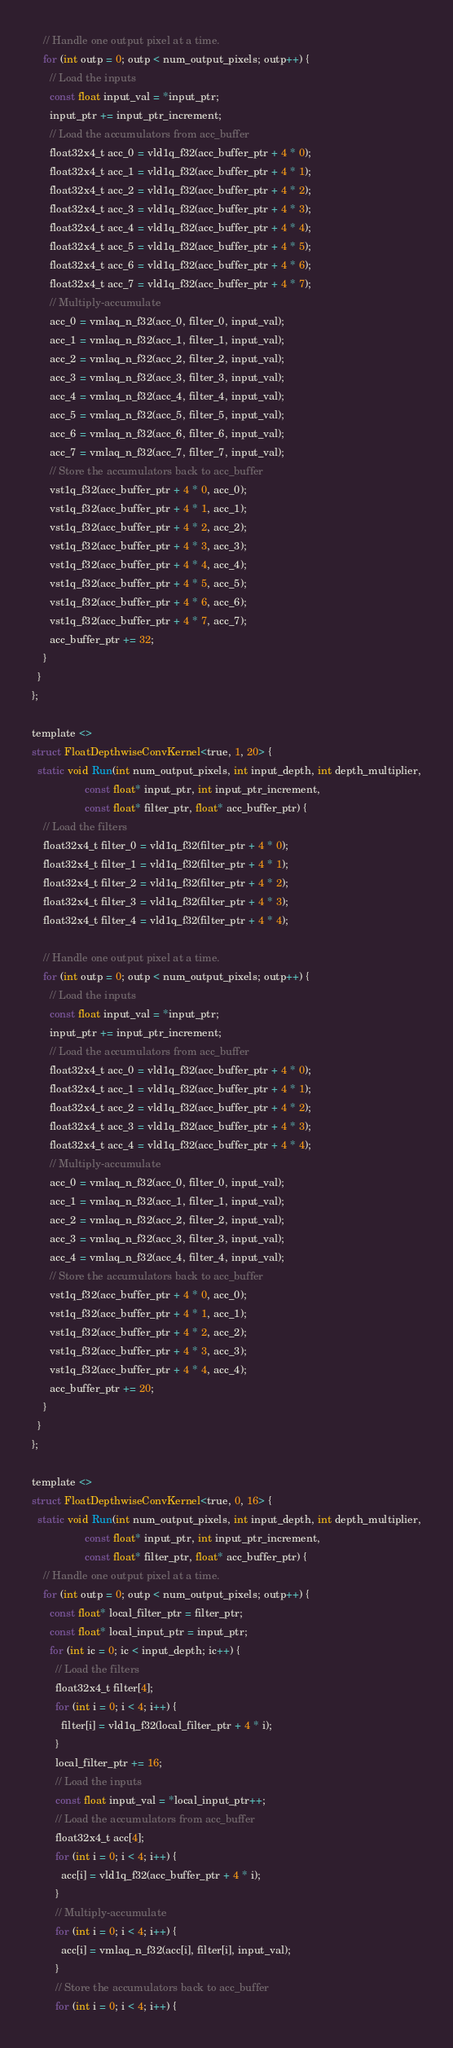Convert code to text. <code><loc_0><loc_0><loc_500><loc_500><_C_>    // Handle one output pixel at a time.
    for (int outp = 0; outp < num_output_pixels; outp++) {
      // Load the inputs
      const float input_val = *input_ptr;
      input_ptr += input_ptr_increment;
      // Load the accumulators from acc_buffer
      float32x4_t acc_0 = vld1q_f32(acc_buffer_ptr + 4 * 0);
      float32x4_t acc_1 = vld1q_f32(acc_buffer_ptr + 4 * 1);
      float32x4_t acc_2 = vld1q_f32(acc_buffer_ptr + 4 * 2);
      float32x4_t acc_3 = vld1q_f32(acc_buffer_ptr + 4 * 3);
      float32x4_t acc_4 = vld1q_f32(acc_buffer_ptr + 4 * 4);
      float32x4_t acc_5 = vld1q_f32(acc_buffer_ptr + 4 * 5);
      float32x4_t acc_6 = vld1q_f32(acc_buffer_ptr + 4 * 6);
      float32x4_t acc_7 = vld1q_f32(acc_buffer_ptr + 4 * 7);
      // Multiply-accumulate
      acc_0 = vmlaq_n_f32(acc_0, filter_0, input_val);
      acc_1 = vmlaq_n_f32(acc_1, filter_1, input_val);
      acc_2 = vmlaq_n_f32(acc_2, filter_2, input_val);
      acc_3 = vmlaq_n_f32(acc_3, filter_3, input_val);
      acc_4 = vmlaq_n_f32(acc_4, filter_4, input_val);
      acc_5 = vmlaq_n_f32(acc_5, filter_5, input_val);
      acc_6 = vmlaq_n_f32(acc_6, filter_6, input_val);
      acc_7 = vmlaq_n_f32(acc_7, filter_7, input_val);
      // Store the accumulators back to acc_buffer
      vst1q_f32(acc_buffer_ptr + 4 * 0, acc_0);
      vst1q_f32(acc_buffer_ptr + 4 * 1, acc_1);
      vst1q_f32(acc_buffer_ptr + 4 * 2, acc_2);
      vst1q_f32(acc_buffer_ptr + 4 * 3, acc_3);
      vst1q_f32(acc_buffer_ptr + 4 * 4, acc_4);
      vst1q_f32(acc_buffer_ptr + 4 * 5, acc_5);
      vst1q_f32(acc_buffer_ptr + 4 * 6, acc_6);
      vst1q_f32(acc_buffer_ptr + 4 * 7, acc_7);
      acc_buffer_ptr += 32;
    }
  }
};

template <>
struct FloatDepthwiseConvKernel<true, 1, 20> {
  static void Run(int num_output_pixels, int input_depth, int depth_multiplier,
                  const float* input_ptr, int input_ptr_increment,
                  const float* filter_ptr, float* acc_buffer_ptr) {
    // Load the filters
    float32x4_t filter_0 = vld1q_f32(filter_ptr + 4 * 0);
    float32x4_t filter_1 = vld1q_f32(filter_ptr + 4 * 1);
    float32x4_t filter_2 = vld1q_f32(filter_ptr + 4 * 2);
    float32x4_t filter_3 = vld1q_f32(filter_ptr + 4 * 3);
    float32x4_t filter_4 = vld1q_f32(filter_ptr + 4 * 4);

    // Handle one output pixel at a time.
    for (int outp = 0; outp < num_output_pixels; outp++) {
      // Load the inputs
      const float input_val = *input_ptr;
      input_ptr += input_ptr_increment;
      // Load the accumulators from acc_buffer
      float32x4_t acc_0 = vld1q_f32(acc_buffer_ptr + 4 * 0);
      float32x4_t acc_1 = vld1q_f32(acc_buffer_ptr + 4 * 1);
      float32x4_t acc_2 = vld1q_f32(acc_buffer_ptr + 4 * 2);
      float32x4_t acc_3 = vld1q_f32(acc_buffer_ptr + 4 * 3);
      float32x4_t acc_4 = vld1q_f32(acc_buffer_ptr + 4 * 4);
      // Multiply-accumulate
      acc_0 = vmlaq_n_f32(acc_0, filter_0, input_val);
      acc_1 = vmlaq_n_f32(acc_1, filter_1, input_val);
      acc_2 = vmlaq_n_f32(acc_2, filter_2, input_val);
      acc_3 = vmlaq_n_f32(acc_3, filter_3, input_val);
      acc_4 = vmlaq_n_f32(acc_4, filter_4, input_val);
      // Store the accumulators back to acc_buffer
      vst1q_f32(acc_buffer_ptr + 4 * 0, acc_0);
      vst1q_f32(acc_buffer_ptr + 4 * 1, acc_1);
      vst1q_f32(acc_buffer_ptr + 4 * 2, acc_2);
      vst1q_f32(acc_buffer_ptr + 4 * 3, acc_3);
      vst1q_f32(acc_buffer_ptr + 4 * 4, acc_4);
      acc_buffer_ptr += 20;
    }
  }
};

template <>
struct FloatDepthwiseConvKernel<true, 0, 16> {
  static void Run(int num_output_pixels, int input_depth, int depth_multiplier,
                  const float* input_ptr, int input_ptr_increment,
                  const float* filter_ptr, float* acc_buffer_ptr) {
    // Handle one output pixel at a time.
    for (int outp = 0; outp < num_output_pixels; outp++) {
      const float* local_filter_ptr = filter_ptr;
      const float* local_input_ptr = input_ptr;
      for (int ic = 0; ic < input_depth; ic++) {
        // Load the filters
        float32x4_t filter[4];
        for (int i = 0; i < 4; i++) {
          filter[i] = vld1q_f32(local_filter_ptr + 4 * i);
        }
        local_filter_ptr += 16;
        // Load the inputs
        const float input_val = *local_input_ptr++;
        // Load the accumulators from acc_buffer
        float32x4_t acc[4];
        for (int i = 0; i < 4; i++) {
          acc[i] = vld1q_f32(acc_buffer_ptr + 4 * i);
        }
        // Multiply-accumulate
        for (int i = 0; i < 4; i++) {
          acc[i] = vmlaq_n_f32(acc[i], filter[i], input_val);
        }
        // Store the accumulators back to acc_buffer
        for (int i = 0; i < 4; i++) {</code> 